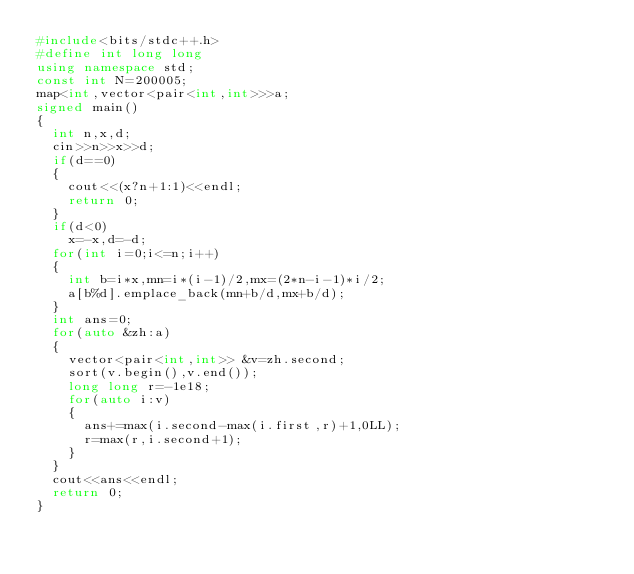Convert code to text. <code><loc_0><loc_0><loc_500><loc_500><_C++_>#include<bits/stdc++.h>
#define int long long
using namespace std;
const int N=200005;
map<int,vector<pair<int,int>>>a;
signed main()
{
	int n,x,d;
	cin>>n>>x>>d;
	if(d==0)
	{
		cout<<(x?n+1:1)<<endl;
		return 0;
	}
	if(d<0)
		x=-x,d=-d;
	for(int i=0;i<=n;i++)
	{
		int b=i*x,mn=i*(i-1)/2,mx=(2*n-i-1)*i/2;
		a[b%d].emplace_back(mn+b/d,mx+b/d);
	}
	int ans=0;
	for(auto &zh:a)
	{
		vector<pair<int,int>> &v=zh.second;
		sort(v.begin(),v.end());
		long long r=-1e18;
		for(auto i:v)
		{
			ans+=max(i.second-max(i.first,r)+1,0LL);
			r=max(r,i.second+1);
		}
	}
	cout<<ans<<endl;
	return 0;
}</code> 